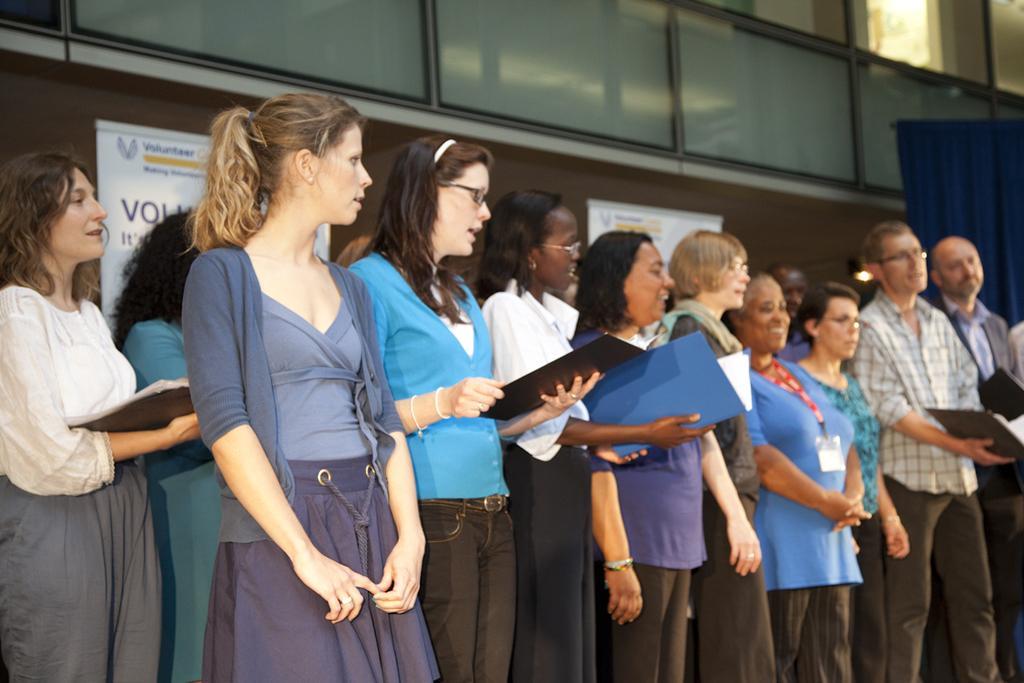Describe this image in one or two sentences. In this image I can see number of persons are standing and few of them are holding files in their hands. I can see a building and a blue colored cloth. I can see few white colored boards attached to the building. 